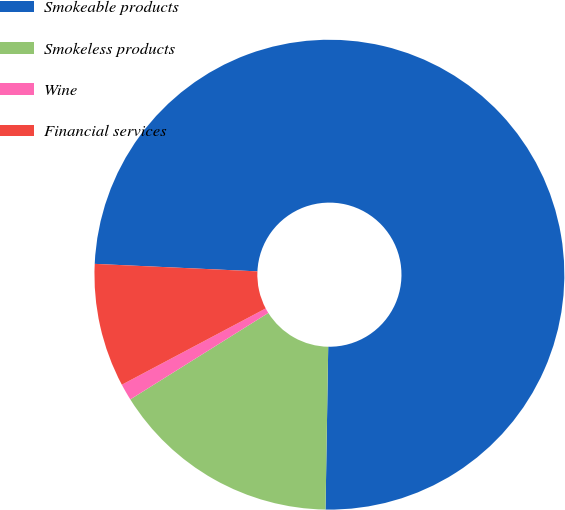<chart> <loc_0><loc_0><loc_500><loc_500><pie_chart><fcel>Smokeable products<fcel>Smokeless products<fcel>Wine<fcel>Financial services<nl><fcel>74.53%<fcel>15.83%<fcel>1.15%<fcel>8.49%<nl></chart> 